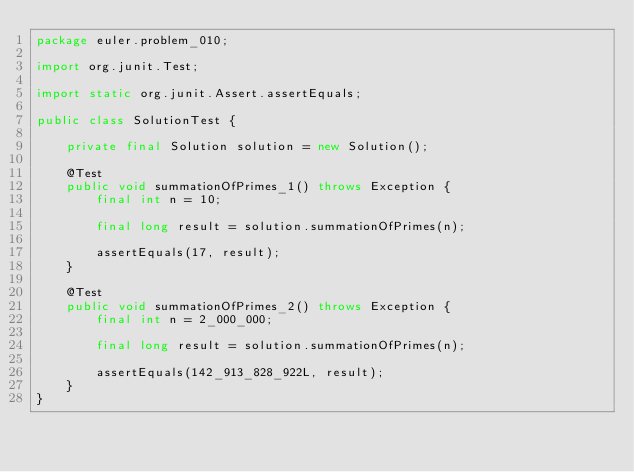Convert code to text. <code><loc_0><loc_0><loc_500><loc_500><_Java_>package euler.problem_010;

import org.junit.Test;

import static org.junit.Assert.assertEquals;

public class SolutionTest {

    private final Solution solution = new Solution();

    @Test
    public void summationOfPrimes_1() throws Exception {
        final int n = 10;

        final long result = solution.summationOfPrimes(n);

        assertEquals(17, result);
    }

    @Test
    public void summationOfPrimes_2() throws Exception {
        final int n = 2_000_000;

        final long result = solution.summationOfPrimes(n);

        assertEquals(142_913_828_922L, result);
    }
}</code> 